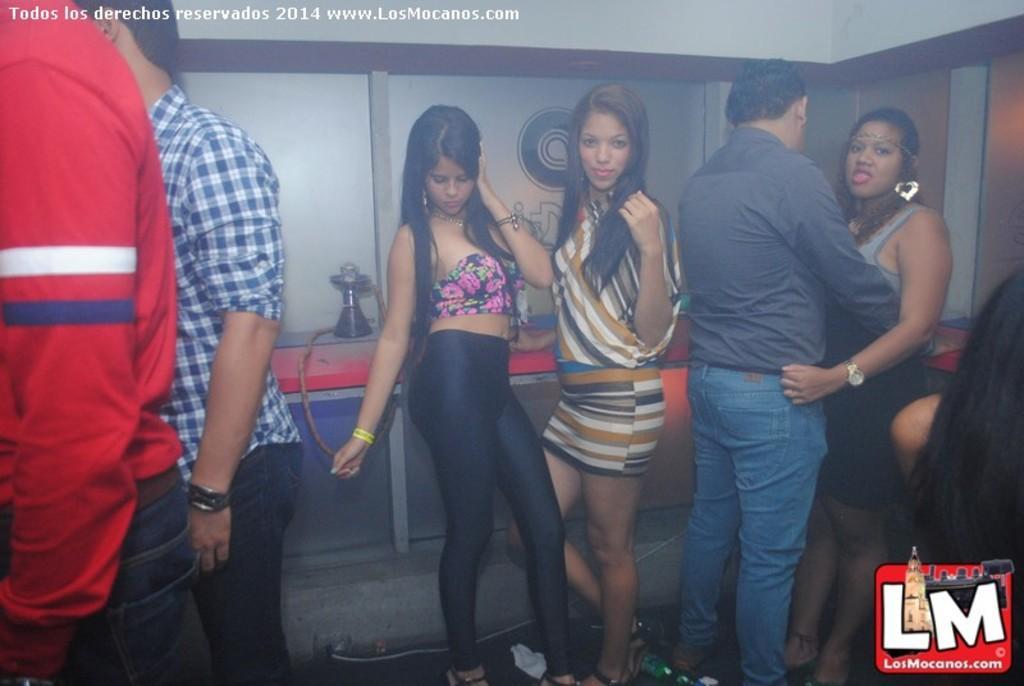Could you give a brief overview of what you see in this image? In this image I can see few people are standing. I can also see a hookah pot in the background and here I can see watermark. 